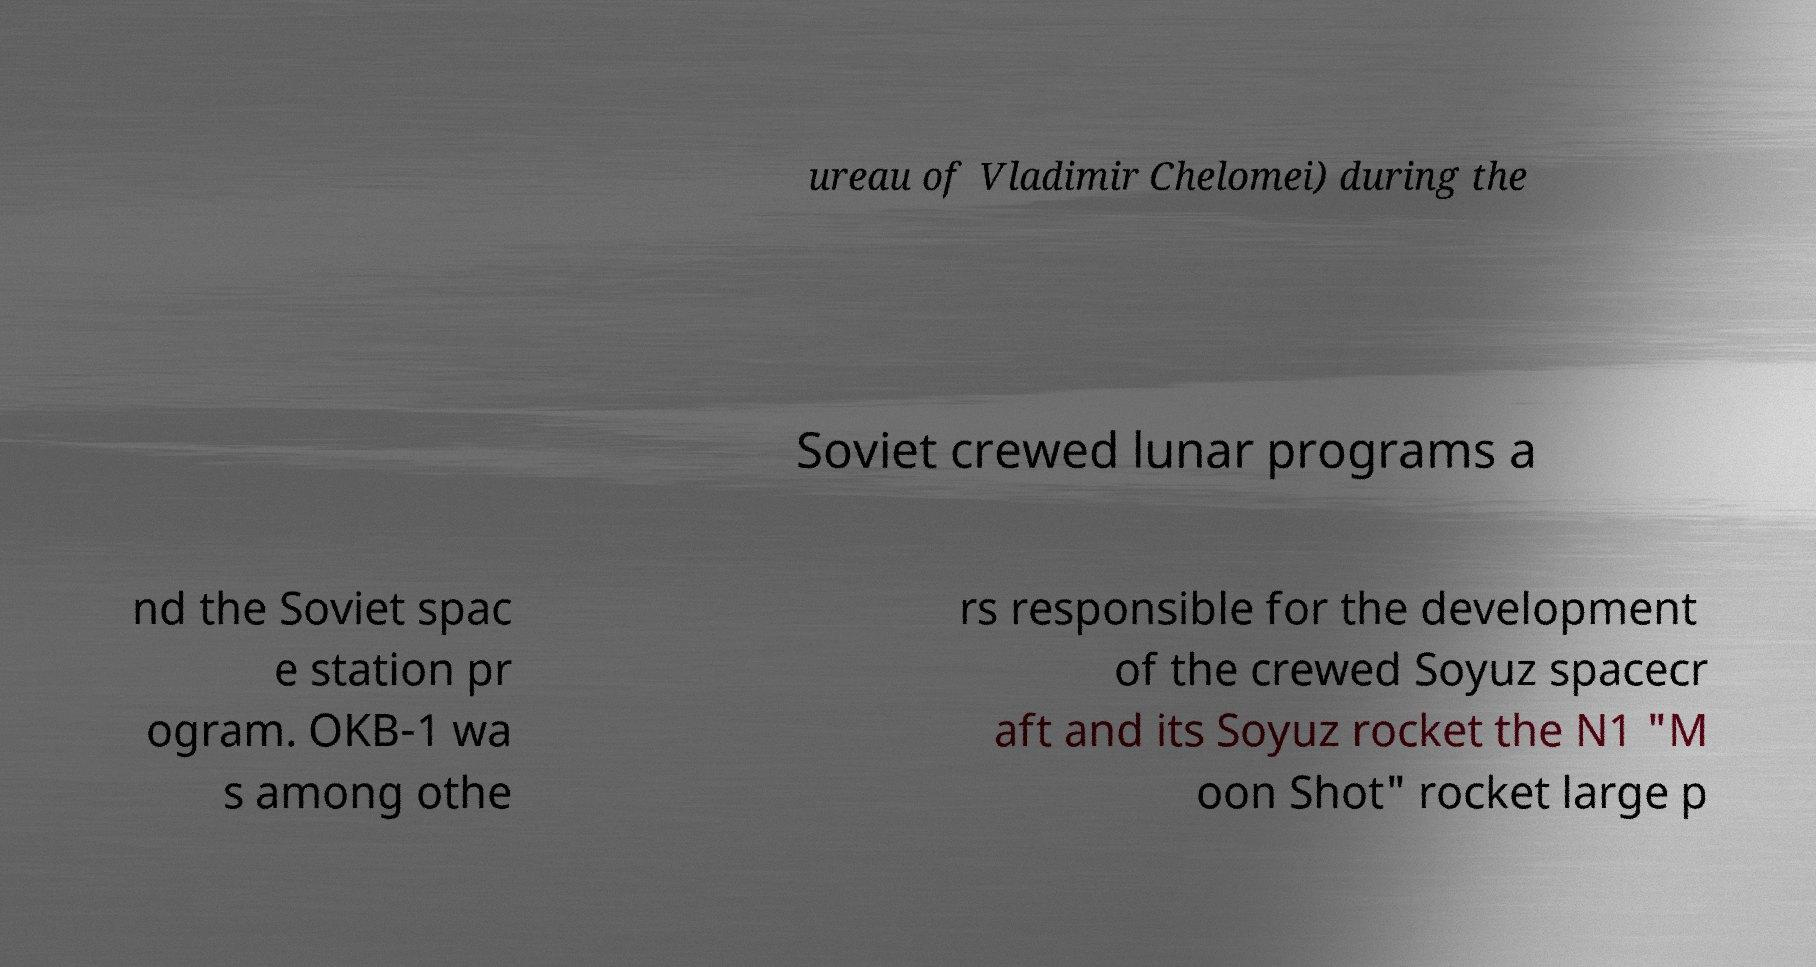Could you assist in decoding the text presented in this image and type it out clearly? ureau of Vladimir Chelomei) during the Soviet crewed lunar programs a nd the Soviet spac e station pr ogram. OKB-1 wa s among othe rs responsible for the development of the crewed Soyuz spacecr aft and its Soyuz rocket the N1 "M oon Shot" rocket large p 